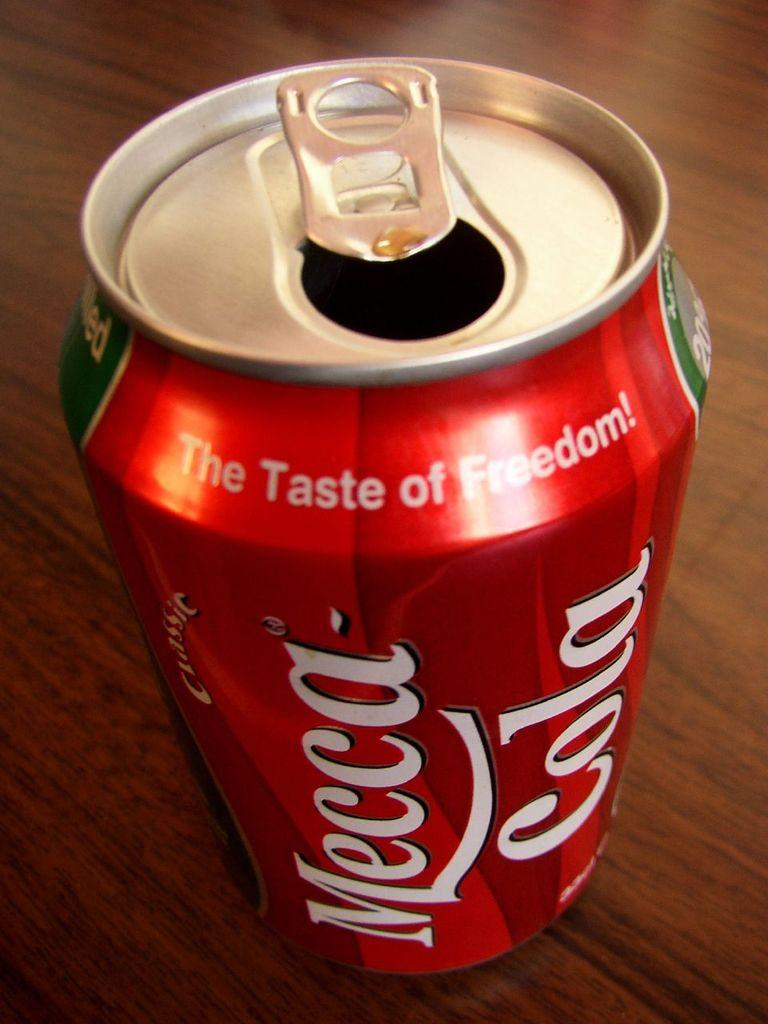<image>
Share a concise interpretation of the image provided. An open can of Mecca Cola sits on the table. 